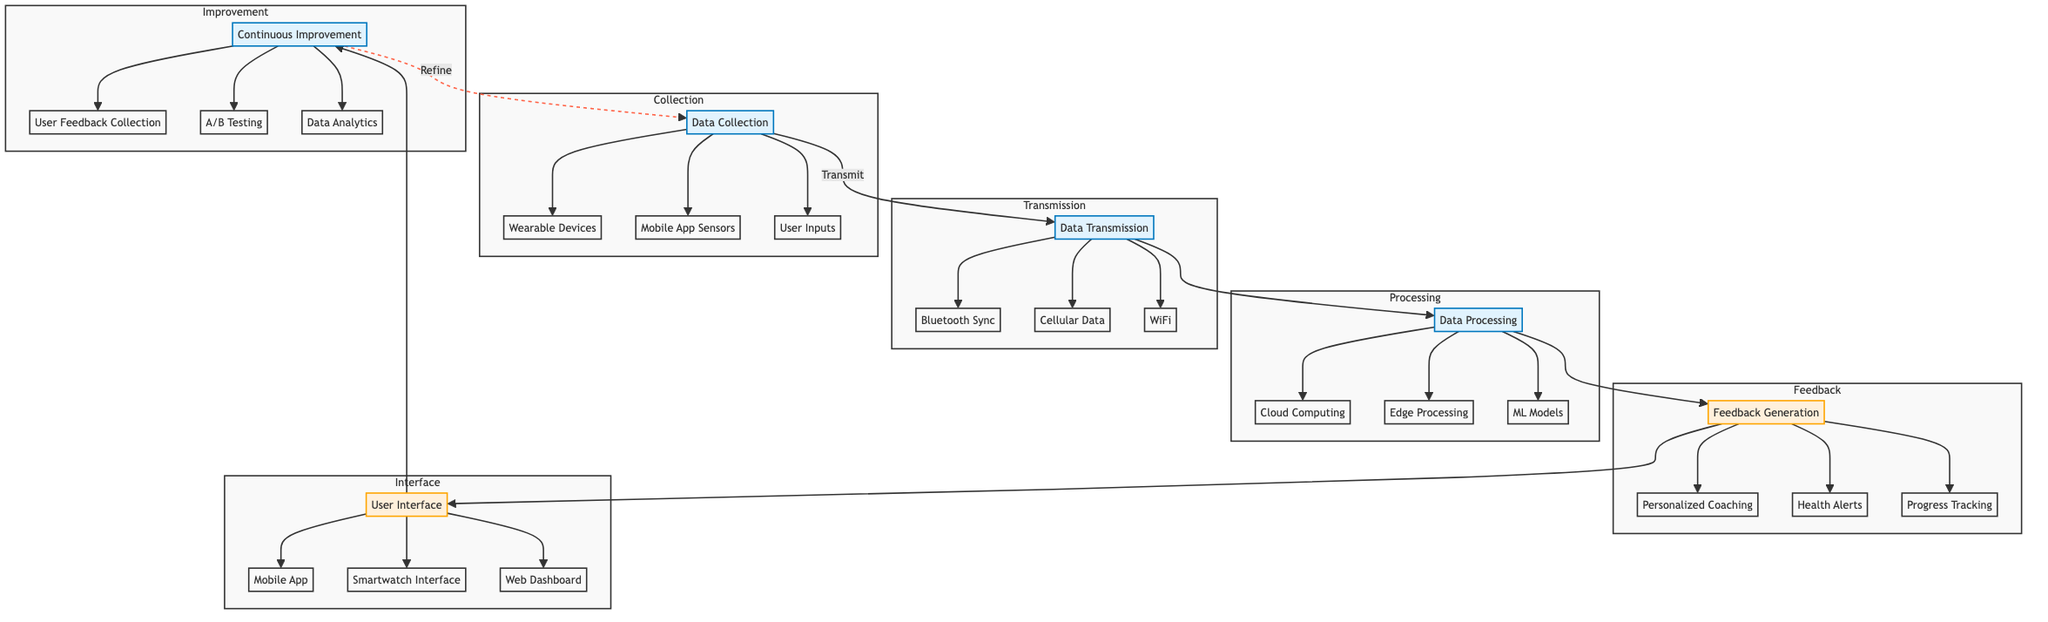What is the first step in the process? The diagram indicates that "Data Collection" is the first step, as it is the initial node from which the process begins.
Answer: Data Collection How many components are in "Data Collection"? In the "Data Collection" section, there are three components: Wearable Devices, Mobile App Sensors, and User Inputs.
Answer: Three What type of data transmission uses low energy modes? The "Bluetooth Sync" in the "Data Transmission" section utilizes low energy modes as part of its functionality.
Answer: Bluetooth Sync Which component is part of "Feedback Generation"? "Health Alerts" is one of the components listed in the "Feedback Generation" section, representing real-time feedback issued to users.
Answer: Health Alerts How does "User Interface" relate to "Feedback Generation"? The "User Interface" receives the feedback generated in the "Feedback Generation" step, indicating a direct flow of information between these two steps.
Answer: Direct flow What is the role of "Continuous Improvement"? "Continuous Improvement" refines algorithms and user experience based on user feedback and performance, demonstrating an ongoing evaluation of the process.
Answer: Refines algorithms and user experience What connection exists between "Continuous Improvement" and "Data Collection"? The diagram shows a dashed line indicating that "Continuous Improvement" refines and largely influences "Data Collection" through feedback, thus creating a loop.
Answer: Feedback loop How many different transmission methods are listed? There are three different transmission methods: Bluetooth Sync, Cellular Data, and WiFi listed under the "Data Transmission" section.
Answer: Three What is one example of a component in "Data Processing"? "Cloud Computing" is an example of a component mentioned under the "Data Processing" section as a method of analyzing the collected data.
Answer: Cloud Computing 